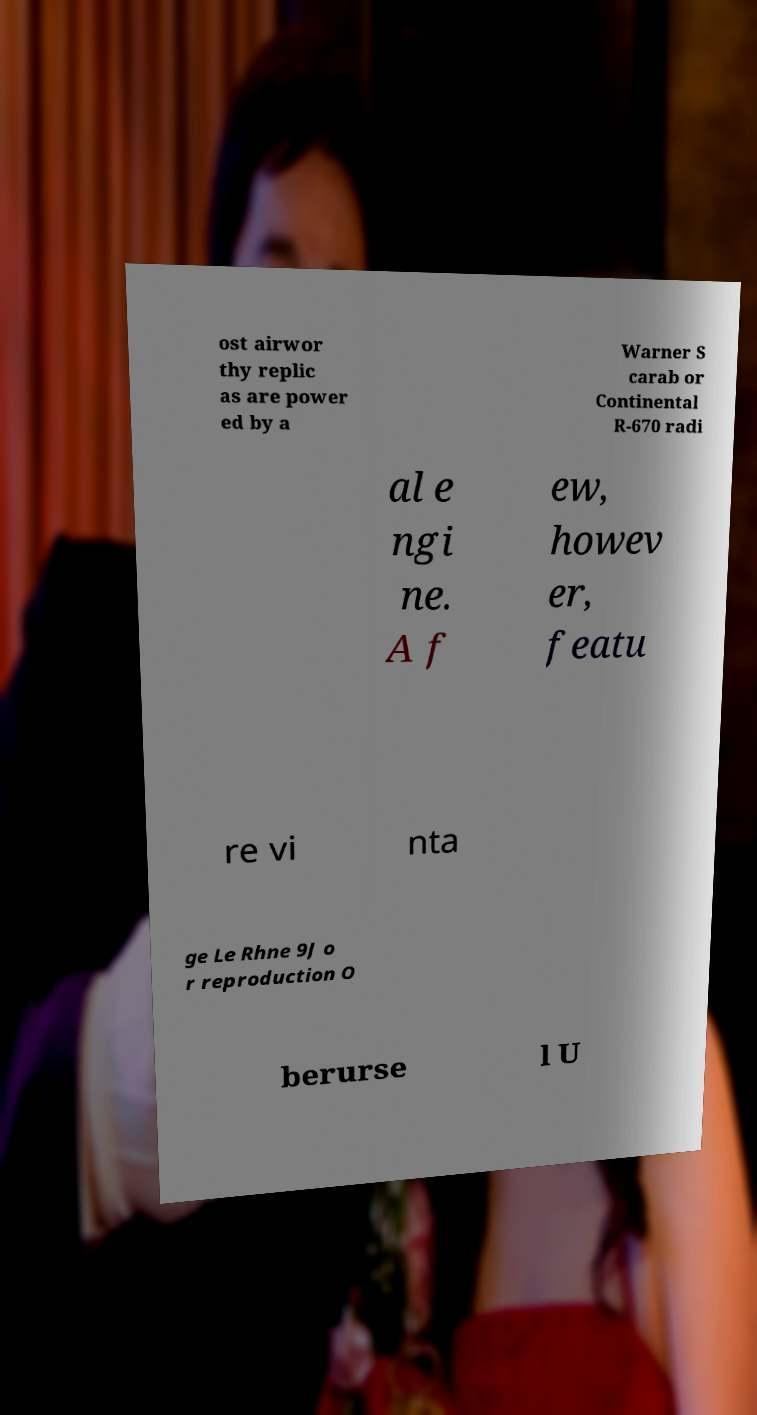Please read and relay the text visible in this image. What does it say? ost airwor thy replic as are power ed by a Warner S carab or Continental R-670 radi al e ngi ne. A f ew, howev er, featu re vi nta ge Le Rhne 9J o r reproduction O berurse l U 